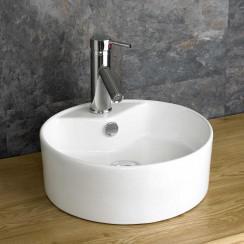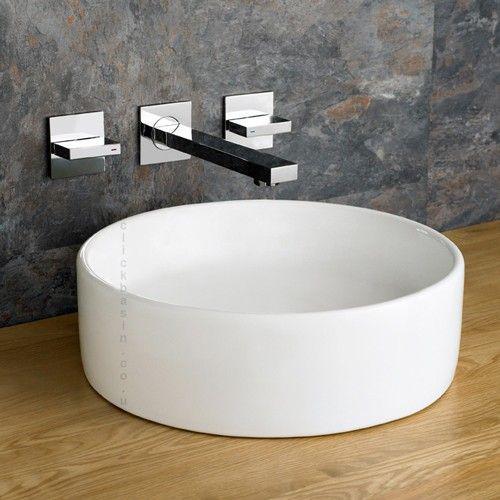The first image is the image on the left, the second image is the image on the right. Evaluate the accuracy of this statement regarding the images: "At least one of the sinks depicted has lever handles flanking the faucet.". Is it true? Answer yes or no. Yes. 